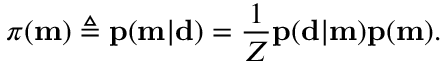<formula> <loc_0><loc_0><loc_500><loc_500>\pi ( m ) \triangle q p ( m | d ) = \frac { 1 } { Z } p ( d | m ) p ( m ) .</formula> 